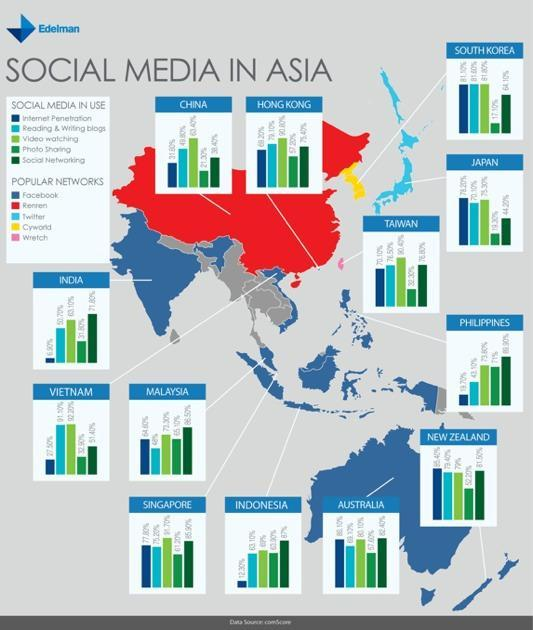Cyworld is found in which country
Answer the question with a short phrase. South Korea which social media is second least used in India Photo sharing Where is wretch popular in taiwan Which is the second most popular social media in Indonesia video watching which is the second least used social media in Australia reading & writing blogs what network is popular in Japan Twitter which is the most popular network in India facebook 